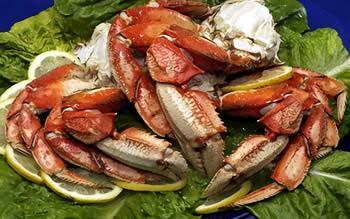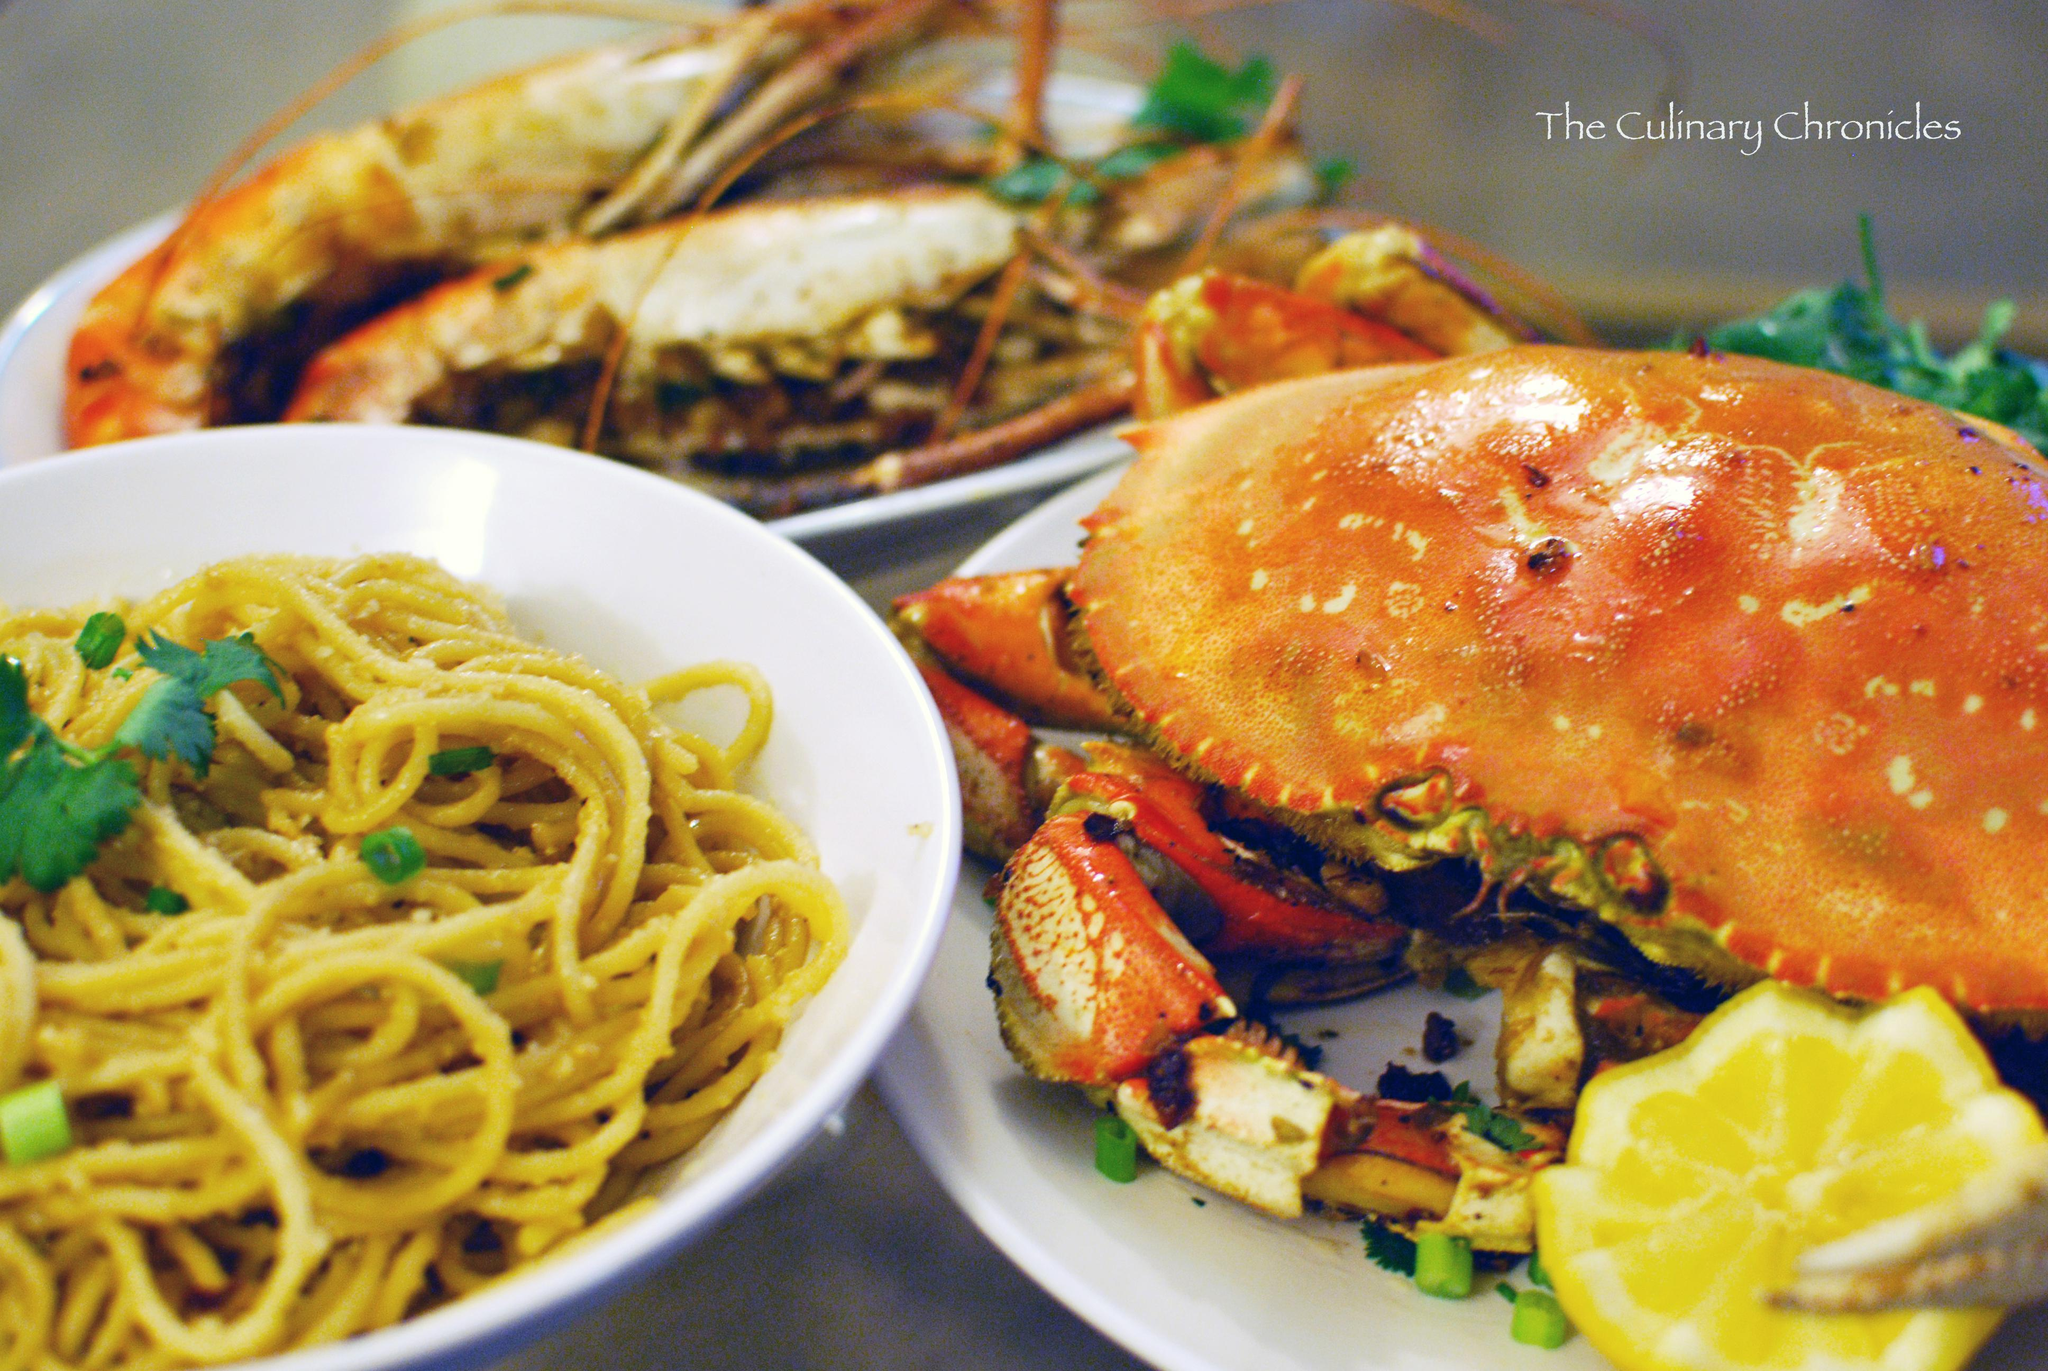The first image is the image on the left, the second image is the image on the right. Considering the images on both sides, is "In at least one image there is a cooked fullcrab facing left and forward." valid? Answer yes or no. Yes. The first image is the image on the left, the second image is the image on the right. For the images shown, is this caption "At least one crab dish is served with a lemon next to the crab on the plate." true? Answer yes or no. Yes. 